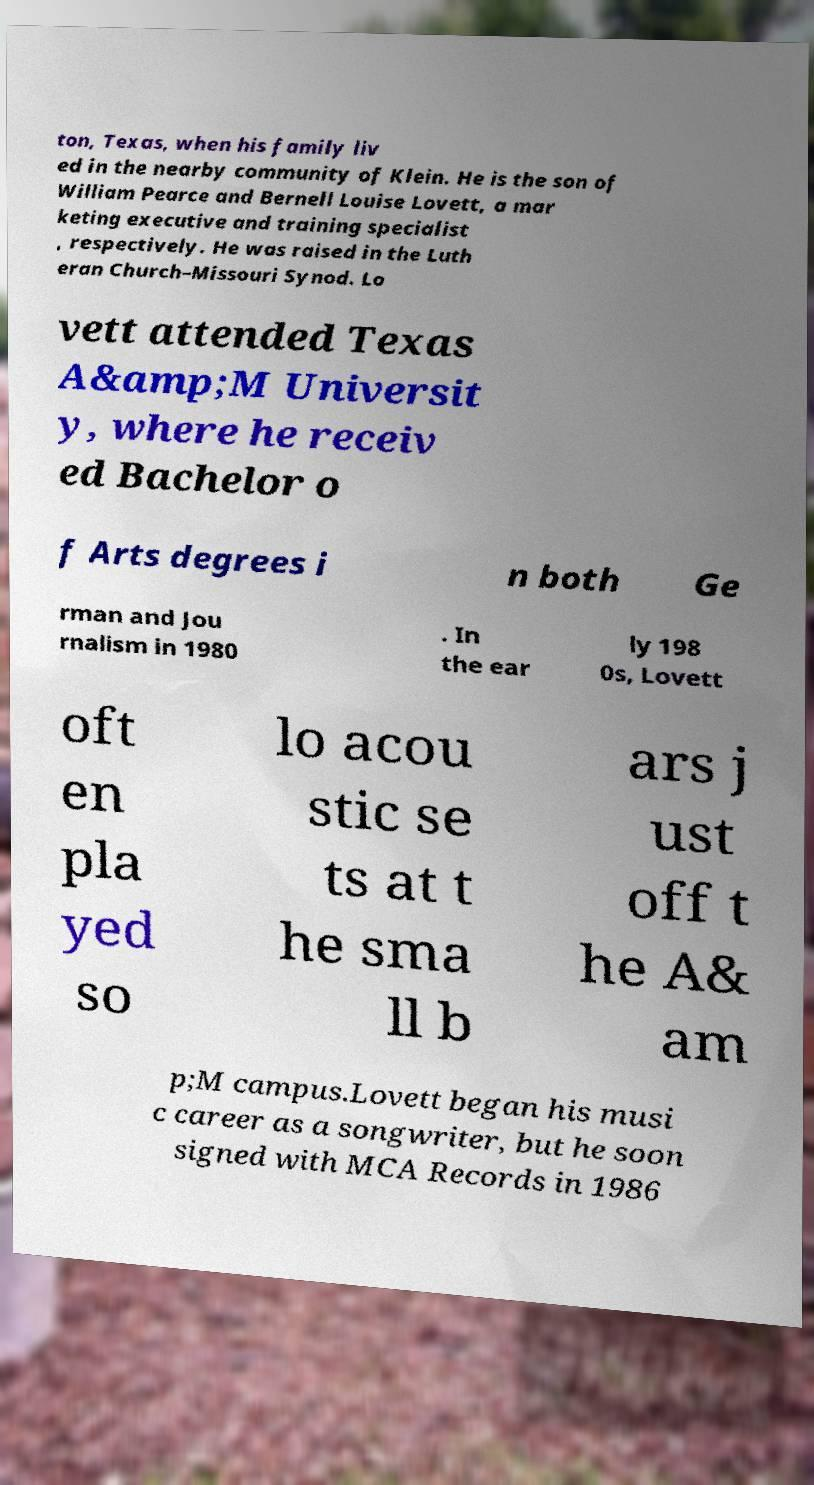I need the written content from this picture converted into text. Can you do that? ton, Texas, when his family liv ed in the nearby community of Klein. He is the son of William Pearce and Bernell Louise Lovett, a mar keting executive and training specialist , respectively. He was raised in the Luth eran Church–Missouri Synod. Lo vett attended Texas A&amp;M Universit y, where he receiv ed Bachelor o f Arts degrees i n both Ge rman and Jou rnalism in 1980 . In the ear ly 198 0s, Lovett oft en pla yed so lo acou stic se ts at t he sma ll b ars j ust off t he A& am p;M campus.Lovett began his musi c career as a songwriter, but he soon signed with MCA Records in 1986 